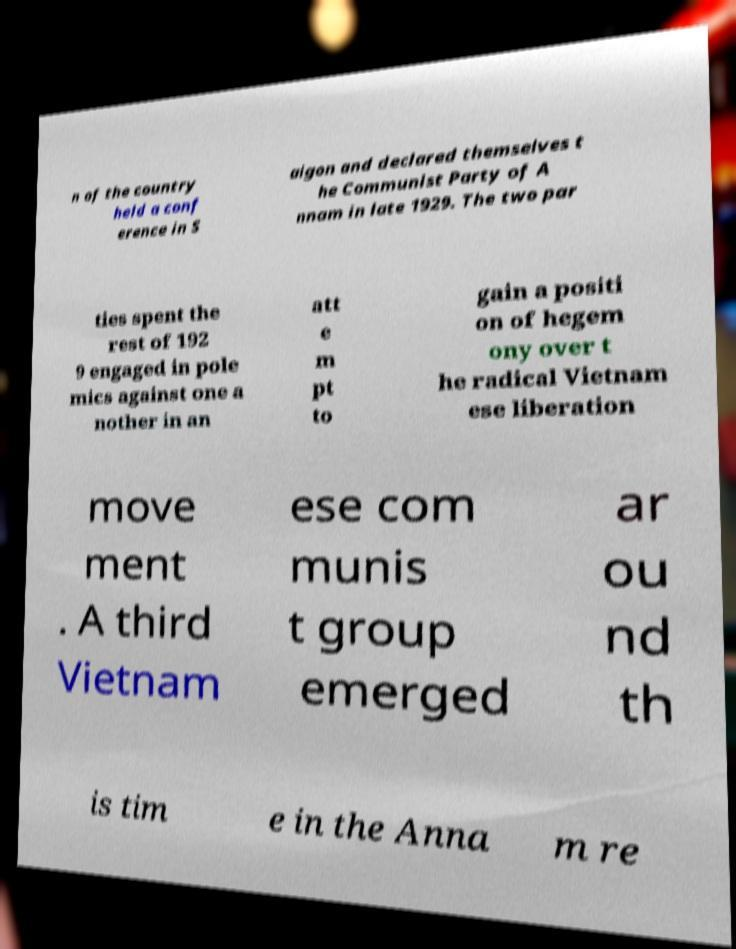What messages or text are displayed in this image? I need them in a readable, typed format. n of the country held a conf erence in S aigon and declared themselves t he Communist Party of A nnam in late 1929. The two par ties spent the rest of 192 9 engaged in pole mics against one a nother in an att e m pt to gain a positi on of hegem ony over t he radical Vietnam ese liberation move ment . A third Vietnam ese com munis t group emerged ar ou nd th is tim e in the Anna m re 